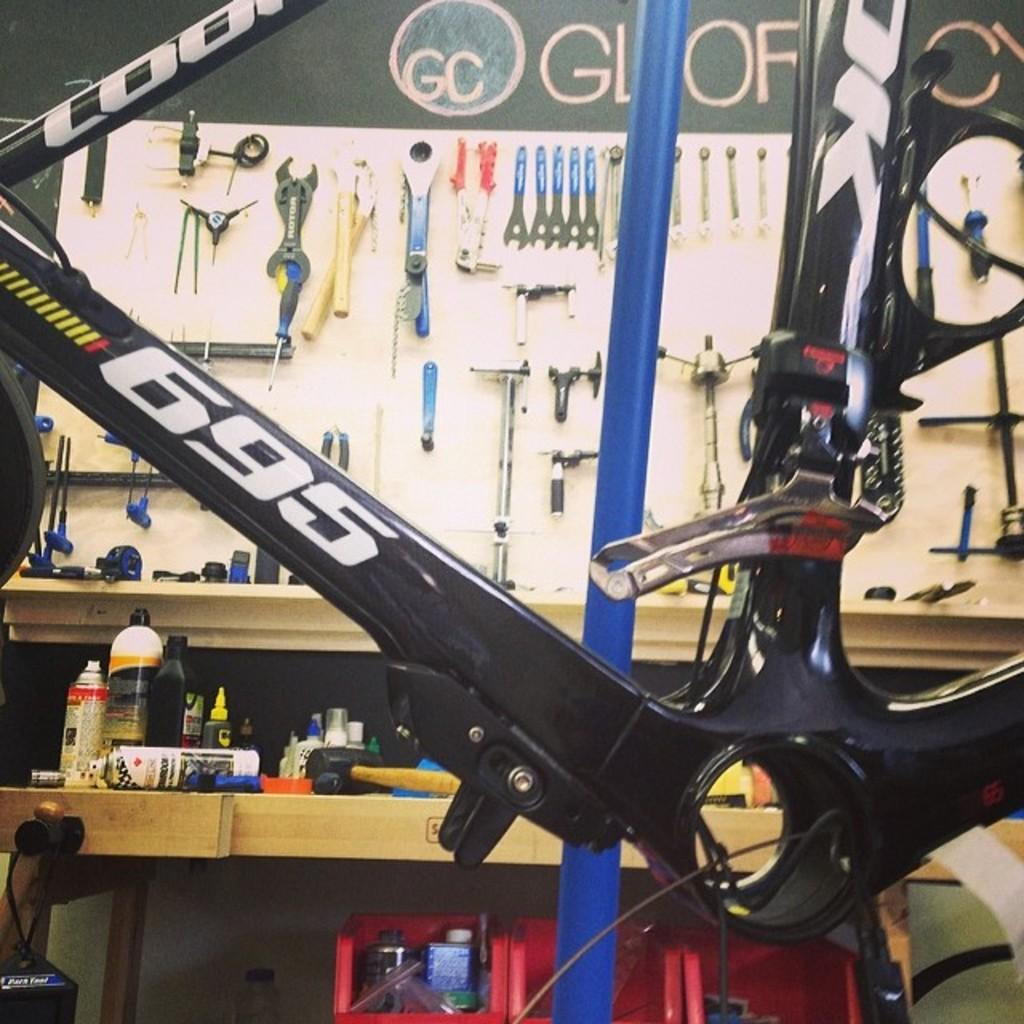What is the main object in the foreground of the image? There is a bicycle in the foreground of the image. What can be seen on the table in the background of the image? There are bottles and instruments on the table in the background of the image. What else is present on the wall in the background of the image? There are tools on the wall in the background of the image. What type of coat is hanging on the bicycle in the image? There is no coat present in the image; it only features a bicycle, bottles, instruments, and tools. What kind of shock can be seen in the image? There is no shock present in the image; it only features a bicycle, bottles, instruments, and tools. 